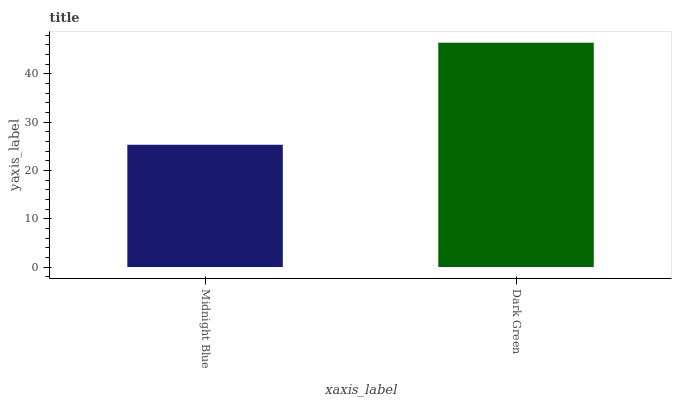Is Dark Green the minimum?
Answer yes or no. No. Is Dark Green greater than Midnight Blue?
Answer yes or no. Yes. Is Midnight Blue less than Dark Green?
Answer yes or no. Yes. Is Midnight Blue greater than Dark Green?
Answer yes or no. No. Is Dark Green less than Midnight Blue?
Answer yes or no. No. Is Dark Green the high median?
Answer yes or no. Yes. Is Midnight Blue the low median?
Answer yes or no. Yes. Is Midnight Blue the high median?
Answer yes or no. No. Is Dark Green the low median?
Answer yes or no. No. 